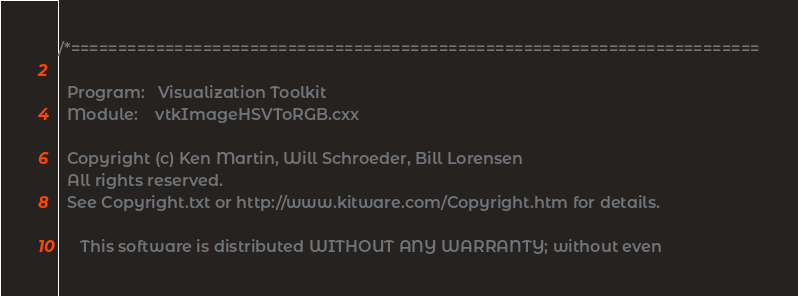Convert code to text. <code><loc_0><loc_0><loc_500><loc_500><_C++_>/*=========================================================================

  Program:   Visualization Toolkit
  Module:    vtkImageHSVToRGB.cxx

  Copyright (c) Ken Martin, Will Schroeder, Bill Lorensen
  All rights reserved.
  See Copyright.txt or http://www.kitware.com/Copyright.htm for details.

     This software is distributed WITHOUT ANY WARRANTY; without even</code> 